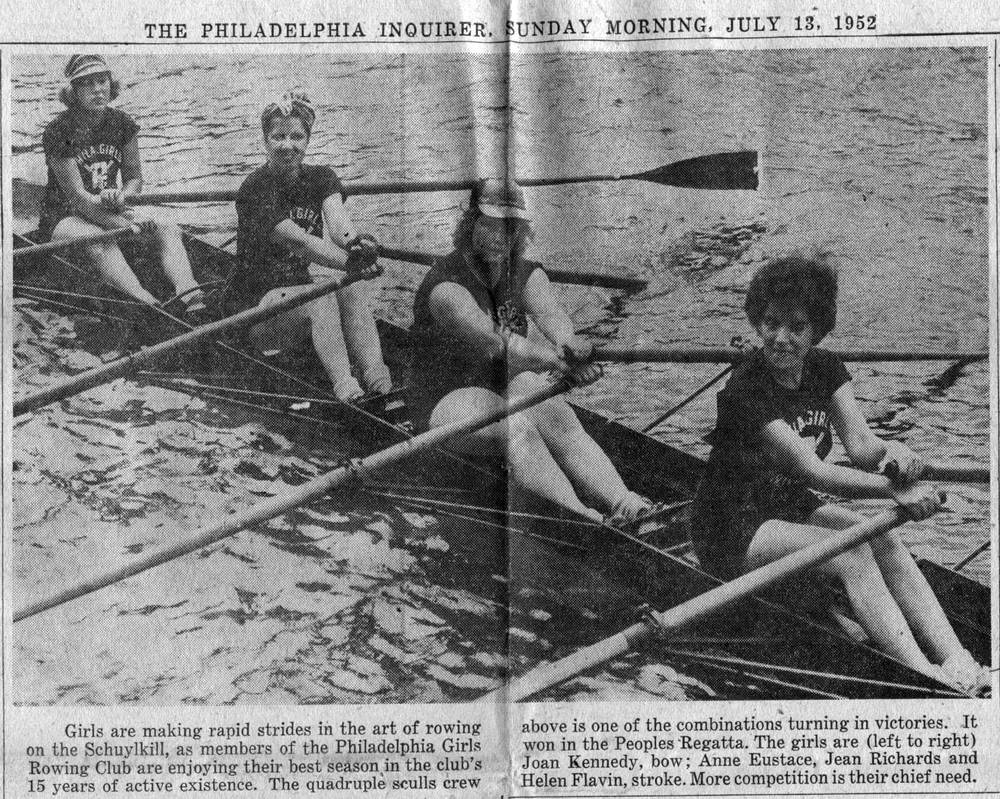What can be deduced regarding the rowers' experience and skill level based on this image? The precise oar alignment and the rowers’ focused expressions denote a high level of skill, suggesting they are seasoned athletes. Their coordination, evident even in a still image, hints at extensive training and experience in the sport of rowing. 